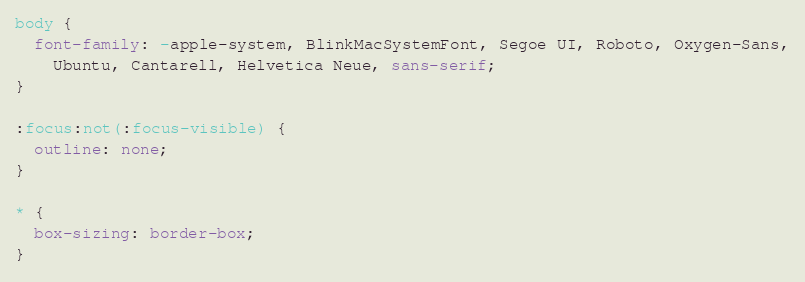Convert code to text. <code><loc_0><loc_0><loc_500><loc_500><_CSS_>body {
  font-family: -apple-system, BlinkMacSystemFont, Segoe UI, Roboto, Oxygen-Sans,
    Ubuntu, Cantarell, Helvetica Neue, sans-serif;
}

:focus:not(:focus-visible) {
  outline: none;
}

* {
  box-sizing: border-box;
}
</code> 